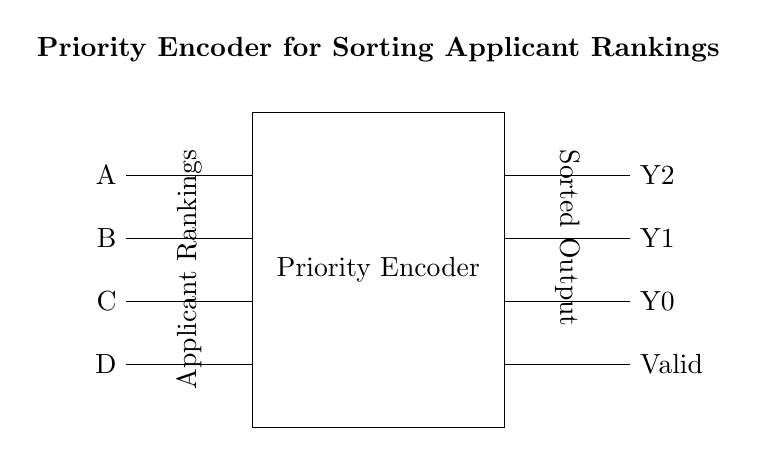What are the input signals to the priority encoder? The input signals to the priority encoder are A, B, C, and D, as indicated on the left side of the circuit diagram.
Answer: A, B, C, D How many output lines does the priority encoder have? The priority encoder has three output lines: Y2, Y1, and Y0, which are clearly depicted on the right side of the circuit diagram.
Answer: Three What does the 'Valid' output indicate? The 'Valid' output indicates whether any of the inputs (A, B, C, D) are active, signifying that at least one signal is being prioritized and processed.
Answer: Indicates active input Which input has the highest priority in the circuit? The input A has the highest priority, as it is positioned first in the input list on the left side and is thus prioritized over B, C, and D.
Answer: A Explain the significance of the output Y2. Output Y2 represents the first significant bit of the encoding, indicating the highest input that is active among the signals. It is part of the binary conversion of the input signals.
Answer: Highest input signal If both A and C are active, what will be the output? If both A and C are active, the priority encoder will prioritize A over C, which means the output will reflect A's position. Therefore, Y2 will be high, denoting that A has the priority, and Y1 and Y0 will be set appropriately based on A only.
Answer: A has priority 